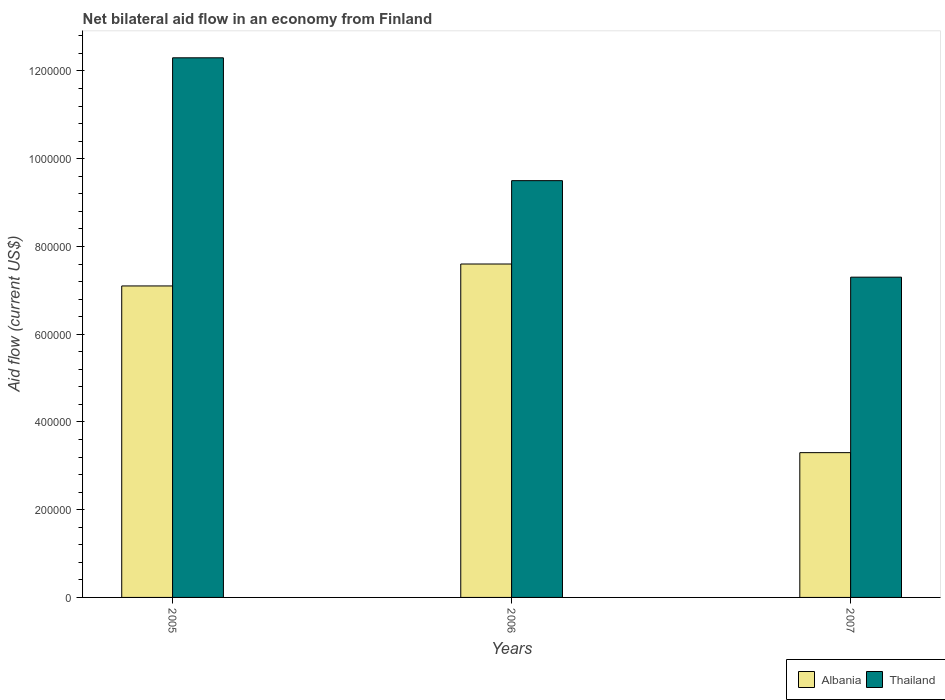How many different coloured bars are there?
Offer a terse response. 2. How many groups of bars are there?
Your answer should be compact. 3. Are the number of bars per tick equal to the number of legend labels?
Offer a terse response. Yes. How many bars are there on the 2nd tick from the left?
Give a very brief answer. 2. What is the label of the 2nd group of bars from the left?
Keep it short and to the point. 2006. In how many cases, is the number of bars for a given year not equal to the number of legend labels?
Provide a succinct answer. 0. What is the net bilateral aid flow in Albania in 2005?
Provide a short and direct response. 7.10e+05. Across all years, what is the maximum net bilateral aid flow in Thailand?
Offer a very short reply. 1.23e+06. Across all years, what is the minimum net bilateral aid flow in Thailand?
Your answer should be very brief. 7.30e+05. What is the total net bilateral aid flow in Thailand in the graph?
Provide a succinct answer. 2.91e+06. What is the difference between the net bilateral aid flow in Albania in 2007 and the net bilateral aid flow in Thailand in 2006?
Your response must be concise. -6.20e+05. What is the average net bilateral aid flow in Albania per year?
Provide a succinct answer. 6.00e+05. In the year 2007, what is the difference between the net bilateral aid flow in Albania and net bilateral aid flow in Thailand?
Your answer should be compact. -4.00e+05. What is the ratio of the net bilateral aid flow in Albania in 2005 to that in 2007?
Your response must be concise. 2.15. Is the net bilateral aid flow in Albania in 2005 less than that in 2007?
Your response must be concise. No. What is the difference between the highest and the second highest net bilateral aid flow in Albania?
Provide a succinct answer. 5.00e+04. In how many years, is the net bilateral aid flow in Albania greater than the average net bilateral aid flow in Albania taken over all years?
Your answer should be very brief. 2. Is the sum of the net bilateral aid flow in Albania in 2005 and 2006 greater than the maximum net bilateral aid flow in Thailand across all years?
Make the answer very short. Yes. What does the 2nd bar from the left in 2005 represents?
Your response must be concise. Thailand. What does the 1st bar from the right in 2005 represents?
Offer a very short reply. Thailand. How many years are there in the graph?
Keep it short and to the point. 3. What is the difference between two consecutive major ticks on the Y-axis?
Ensure brevity in your answer.  2.00e+05. Does the graph contain grids?
Your response must be concise. No. Where does the legend appear in the graph?
Ensure brevity in your answer.  Bottom right. How are the legend labels stacked?
Provide a succinct answer. Horizontal. What is the title of the graph?
Offer a very short reply. Net bilateral aid flow in an economy from Finland. What is the Aid flow (current US$) in Albania in 2005?
Ensure brevity in your answer.  7.10e+05. What is the Aid flow (current US$) in Thailand in 2005?
Provide a short and direct response. 1.23e+06. What is the Aid flow (current US$) of Albania in 2006?
Give a very brief answer. 7.60e+05. What is the Aid flow (current US$) of Thailand in 2006?
Make the answer very short. 9.50e+05. What is the Aid flow (current US$) in Albania in 2007?
Offer a very short reply. 3.30e+05. What is the Aid flow (current US$) in Thailand in 2007?
Offer a terse response. 7.30e+05. Across all years, what is the maximum Aid flow (current US$) of Albania?
Your answer should be very brief. 7.60e+05. Across all years, what is the maximum Aid flow (current US$) of Thailand?
Your answer should be very brief. 1.23e+06. Across all years, what is the minimum Aid flow (current US$) in Albania?
Keep it short and to the point. 3.30e+05. Across all years, what is the minimum Aid flow (current US$) in Thailand?
Provide a short and direct response. 7.30e+05. What is the total Aid flow (current US$) in Albania in the graph?
Your response must be concise. 1.80e+06. What is the total Aid flow (current US$) in Thailand in the graph?
Provide a succinct answer. 2.91e+06. What is the difference between the Aid flow (current US$) of Thailand in 2005 and that in 2006?
Your response must be concise. 2.80e+05. What is the difference between the Aid flow (current US$) of Thailand in 2005 and that in 2007?
Make the answer very short. 5.00e+05. What is the difference between the Aid flow (current US$) of Albania in 2006 and that in 2007?
Provide a succinct answer. 4.30e+05. What is the difference between the Aid flow (current US$) in Albania in 2005 and the Aid flow (current US$) in Thailand in 2006?
Ensure brevity in your answer.  -2.40e+05. What is the difference between the Aid flow (current US$) in Albania in 2006 and the Aid flow (current US$) in Thailand in 2007?
Your answer should be compact. 3.00e+04. What is the average Aid flow (current US$) of Albania per year?
Ensure brevity in your answer.  6.00e+05. What is the average Aid flow (current US$) of Thailand per year?
Your response must be concise. 9.70e+05. In the year 2005, what is the difference between the Aid flow (current US$) in Albania and Aid flow (current US$) in Thailand?
Provide a short and direct response. -5.20e+05. In the year 2007, what is the difference between the Aid flow (current US$) of Albania and Aid flow (current US$) of Thailand?
Offer a very short reply. -4.00e+05. What is the ratio of the Aid flow (current US$) in Albania in 2005 to that in 2006?
Your response must be concise. 0.93. What is the ratio of the Aid flow (current US$) in Thailand in 2005 to that in 2006?
Offer a very short reply. 1.29. What is the ratio of the Aid flow (current US$) in Albania in 2005 to that in 2007?
Keep it short and to the point. 2.15. What is the ratio of the Aid flow (current US$) of Thailand in 2005 to that in 2007?
Your answer should be very brief. 1.68. What is the ratio of the Aid flow (current US$) in Albania in 2006 to that in 2007?
Offer a terse response. 2.3. What is the ratio of the Aid flow (current US$) of Thailand in 2006 to that in 2007?
Keep it short and to the point. 1.3. What is the difference between the highest and the second highest Aid flow (current US$) of Thailand?
Provide a succinct answer. 2.80e+05. What is the difference between the highest and the lowest Aid flow (current US$) in Thailand?
Offer a terse response. 5.00e+05. 